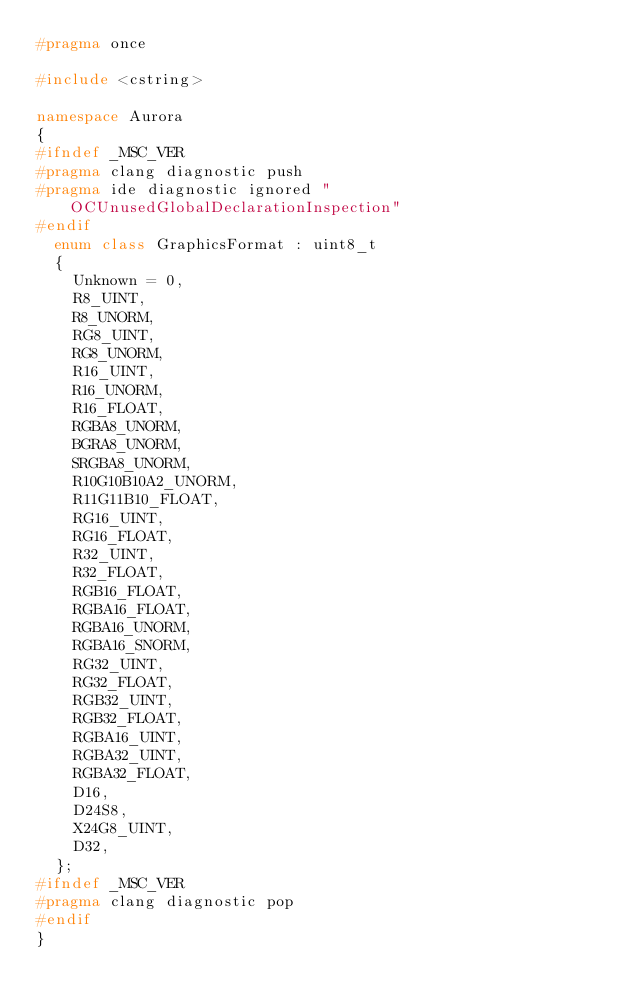<code> <loc_0><loc_0><loc_500><loc_500><_C++_>#pragma once

#include <cstring>

namespace Aurora
{
#ifndef _MSC_VER
#pragma clang diagnostic push
#pragma ide diagnostic ignored "OCUnusedGlobalDeclarationInspection"
#endif
	enum class GraphicsFormat : uint8_t
	{
		Unknown = 0,
		R8_UINT,
		R8_UNORM,
		RG8_UINT,
		RG8_UNORM,
		R16_UINT,
		R16_UNORM,
		R16_FLOAT,
		RGBA8_UNORM,
		BGRA8_UNORM,
		SRGBA8_UNORM,
		R10G10B10A2_UNORM,
		R11G11B10_FLOAT,
		RG16_UINT,
		RG16_FLOAT,
		R32_UINT,
		R32_FLOAT,
		RGB16_FLOAT,
		RGBA16_FLOAT,
		RGBA16_UNORM,
		RGBA16_SNORM,
		RG32_UINT,
		RG32_FLOAT,
		RGB32_UINT,
		RGB32_FLOAT,
		RGBA16_UINT,
		RGBA32_UINT,
		RGBA32_FLOAT,
		D16,
		D24S8,
		X24G8_UINT,
		D32,
	};
#ifndef _MSC_VER
#pragma clang diagnostic pop
#endif
}</code> 